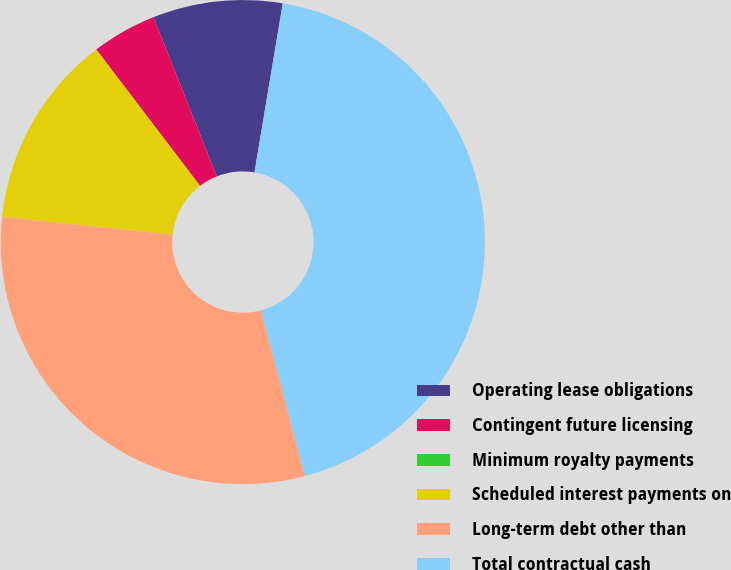Convert chart to OTSL. <chart><loc_0><loc_0><loc_500><loc_500><pie_chart><fcel>Operating lease obligations<fcel>Contingent future licensing<fcel>Minimum royalty payments<fcel>Scheduled interest payments on<fcel>Long-term debt other than<fcel>Total contractual cash<nl><fcel>8.66%<fcel>4.33%<fcel>0.01%<fcel>12.98%<fcel>30.79%<fcel>43.24%<nl></chart> 